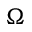Convert formula to latex. <formula><loc_0><loc_0><loc_500><loc_500>\Omega</formula> 